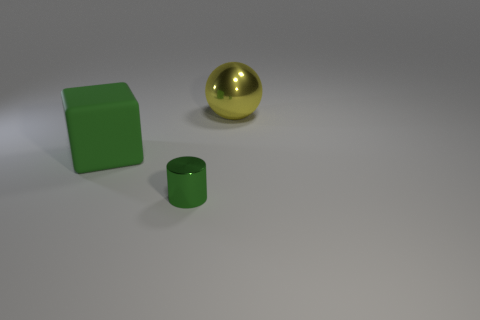Subtract 1 cylinders. How many cylinders are left? 0 Add 3 big cyan cylinders. How many objects exist? 6 Subtract all big cyan shiny things. Subtract all small metal things. How many objects are left? 2 Add 2 large yellow metal spheres. How many large yellow metal spheres are left? 3 Add 3 spheres. How many spheres exist? 4 Subtract 0 cyan balls. How many objects are left? 3 Subtract all spheres. How many objects are left? 2 